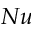Convert formula to latex. <formula><loc_0><loc_0><loc_500><loc_500>N u</formula> 